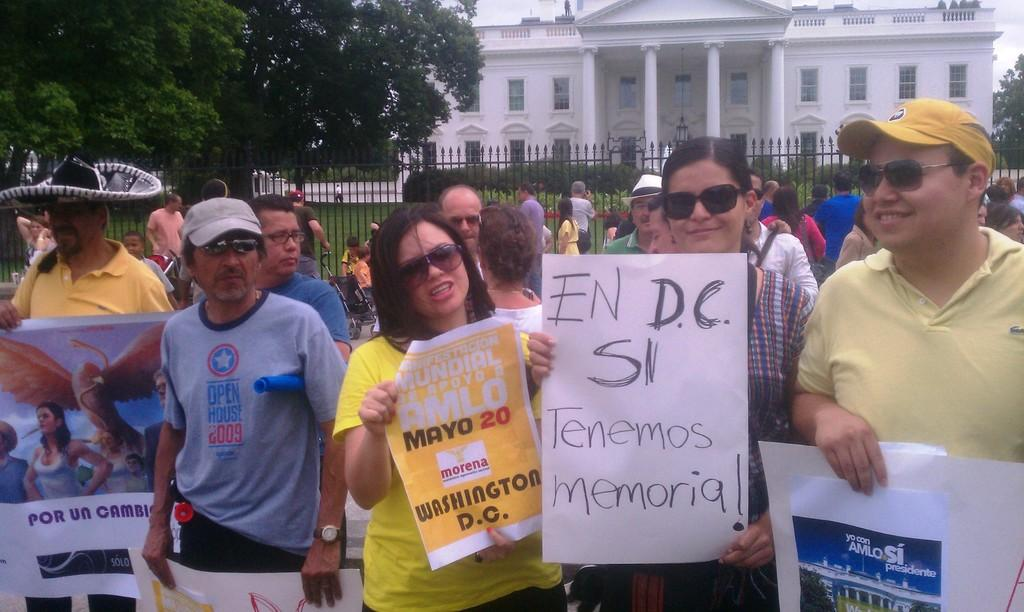Who or what is present in the image? There are people in the image. What are the people holding in the image? The people are holding banners. What can be seen in the background of the image? There is a fence, a building, plants, and trees in the background of the image. How does the wave affect the people in the image? There is no wave present in the image; it is a group of people holding banners with a background of a fence, a building, plants, and trees. 